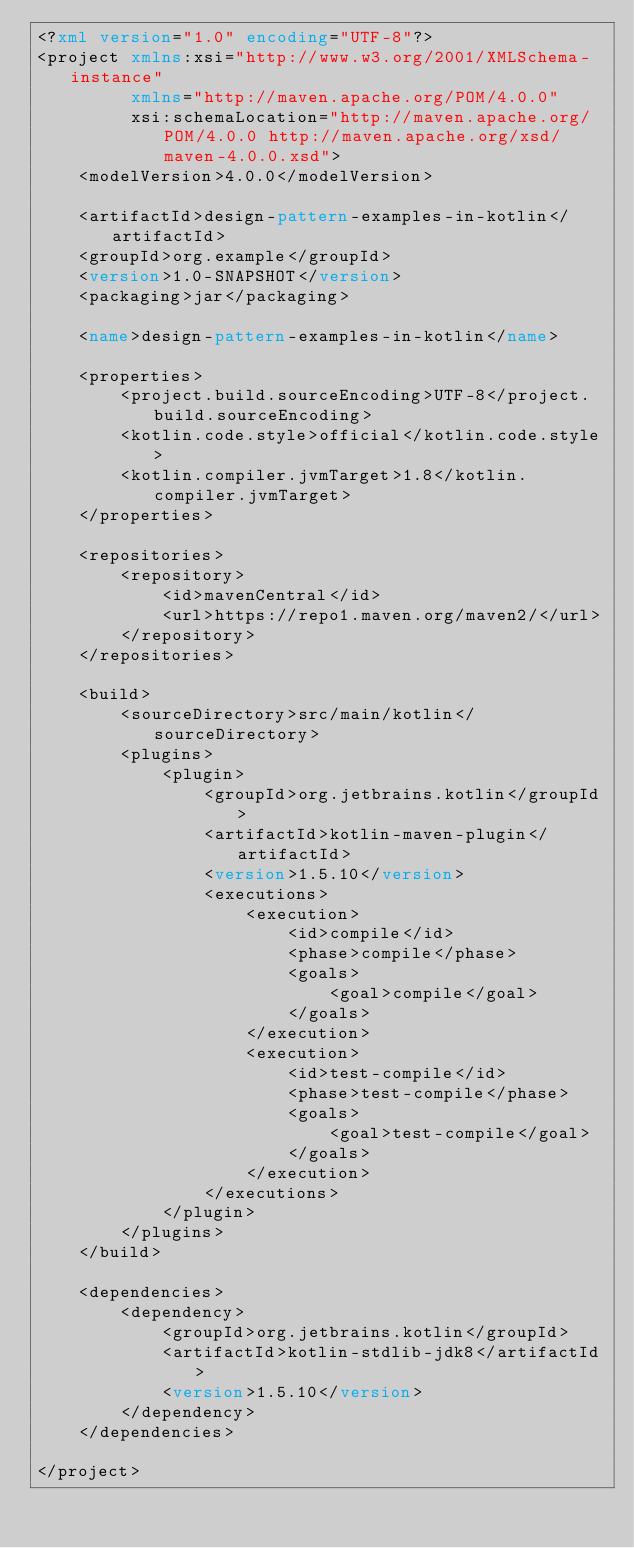Convert code to text. <code><loc_0><loc_0><loc_500><loc_500><_XML_><?xml version="1.0" encoding="UTF-8"?>
<project xmlns:xsi="http://www.w3.org/2001/XMLSchema-instance"
         xmlns="http://maven.apache.org/POM/4.0.0"
         xsi:schemaLocation="http://maven.apache.org/POM/4.0.0 http://maven.apache.org/xsd/maven-4.0.0.xsd">
    <modelVersion>4.0.0</modelVersion>

    <artifactId>design-pattern-examples-in-kotlin</artifactId>
    <groupId>org.example</groupId>
    <version>1.0-SNAPSHOT</version>
    <packaging>jar</packaging>

    <name>design-pattern-examples-in-kotlin</name>

    <properties>
        <project.build.sourceEncoding>UTF-8</project.build.sourceEncoding>
        <kotlin.code.style>official</kotlin.code.style>
        <kotlin.compiler.jvmTarget>1.8</kotlin.compiler.jvmTarget>
    </properties>

    <repositories>
        <repository>
            <id>mavenCentral</id>
            <url>https://repo1.maven.org/maven2/</url>
        </repository>
    </repositories>

    <build>
        <sourceDirectory>src/main/kotlin</sourceDirectory>
        <plugins>
            <plugin>
                <groupId>org.jetbrains.kotlin</groupId>
                <artifactId>kotlin-maven-plugin</artifactId>
                <version>1.5.10</version>
                <executions>
                    <execution>
                        <id>compile</id>
                        <phase>compile</phase>
                        <goals>
                            <goal>compile</goal>
                        </goals>
                    </execution>
                    <execution>
                        <id>test-compile</id>
                        <phase>test-compile</phase>
                        <goals>
                            <goal>test-compile</goal>
                        </goals>
                    </execution>
                </executions>
            </plugin>
        </plugins>
    </build>

    <dependencies>
        <dependency>
            <groupId>org.jetbrains.kotlin</groupId>
            <artifactId>kotlin-stdlib-jdk8</artifactId>
            <version>1.5.10</version>
        </dependency>
    </dependencies>

</project></code> 